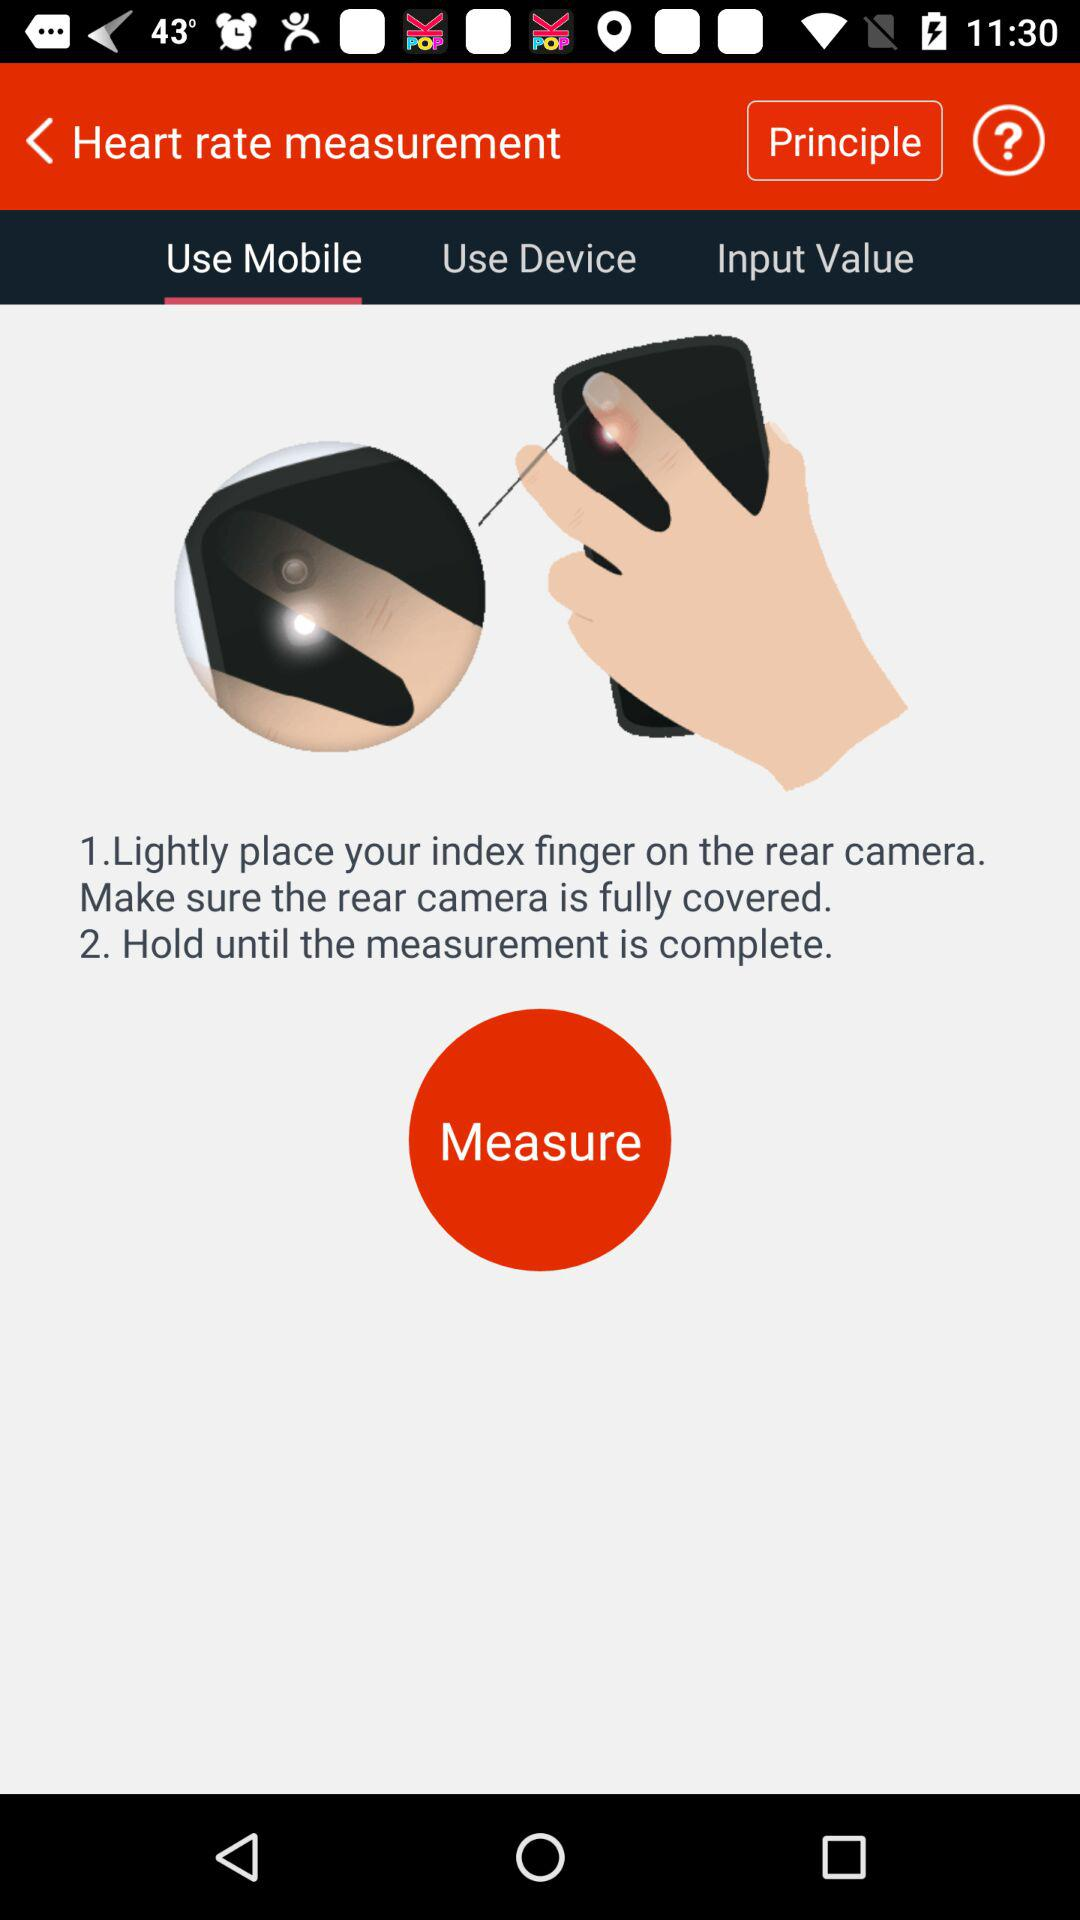Which tab is selected? The selected tab is "Use Mobile". 